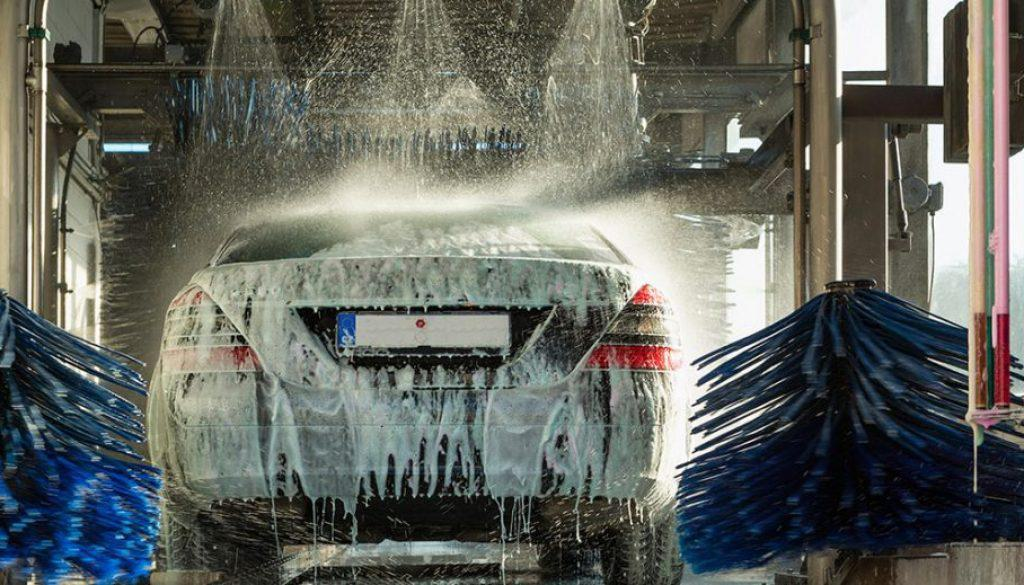Is there anyone in the car? It's not possible to tell if there's someone in the car since the windows appear to be obscured by water and foam. 